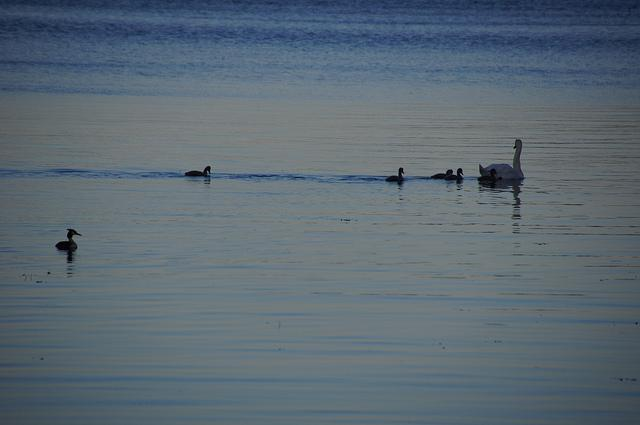What type of birds are the little ones?

Choices:
A) seagull
B) swan
C) duck
D) goose swan 